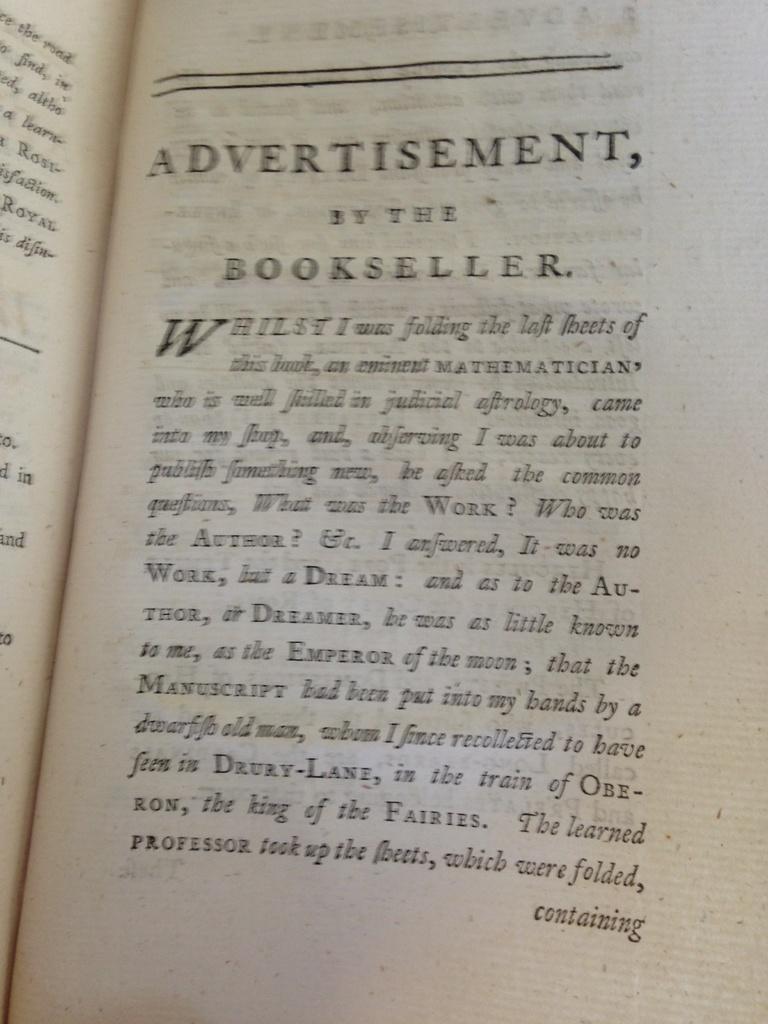What is the biggest word?
Give a very brief answer. Advertisement. 